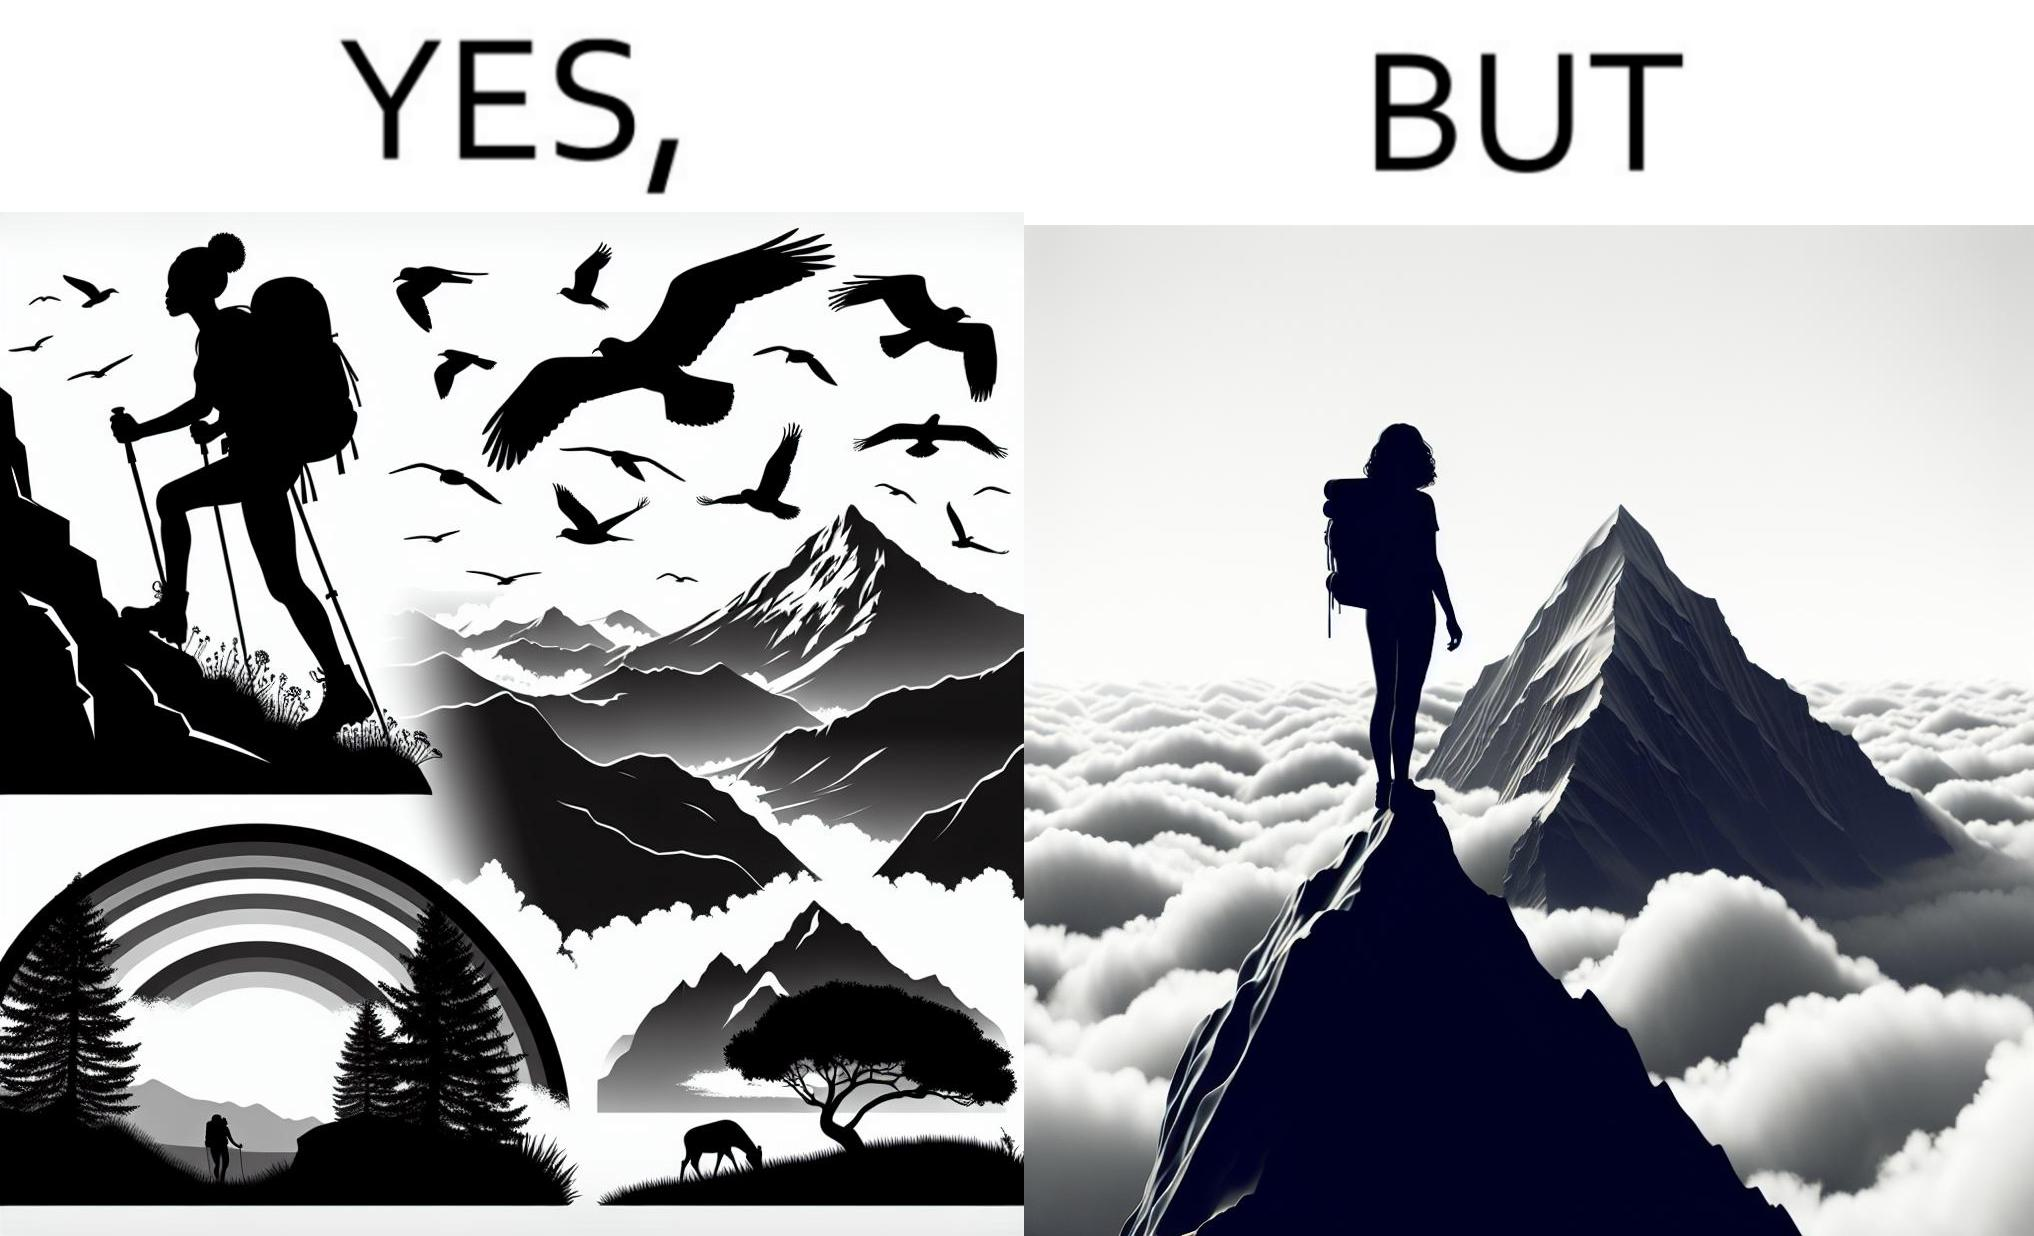Would you classify this image as satirical? Yes, this image is satirical. 